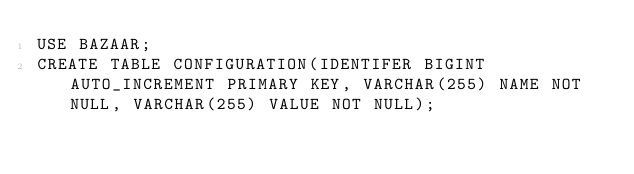<code> <loc_0><loc_0><loc_500><loc_500><_SQL_>USE BAZAAR;
CREATE TABLE CONFIGURATION(IDENTIFER BIGINT AUTO_INCREMENT PRIMARY KEY, VARCHAR(255) NAME NOT NULL, VARCHAR(255) VALUE NOT NULL);</code> 